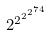Convert formula to latex. <formula><loc_0><loc_0><loc_500><loc_500>2 ^ { 2 ^ { 2 ^ { 2 ^ { 7 4 } } } }</formula> 